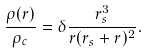Convert formula to latex. <formula><loc_0><loc_0><loc_500><loc_500>\frac { \rho ( r ) } { \rho _ { c } } = \delta \frac { r _ { s } ^ { 3 } } { r ( r _ { s } + r ) ^ { 2 } } .</formula> 